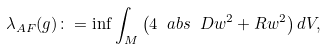Convert formula to latex. <formula><loc_0><loc_0><loc_500><loc_500>\lambda _ { A F } ( g ) \colon = \inf \int _ { M } \left ( 4 \ a b s { \ D w } ^ { 2 } + R w ^ { 2 } \right ) d V ,</formula> 